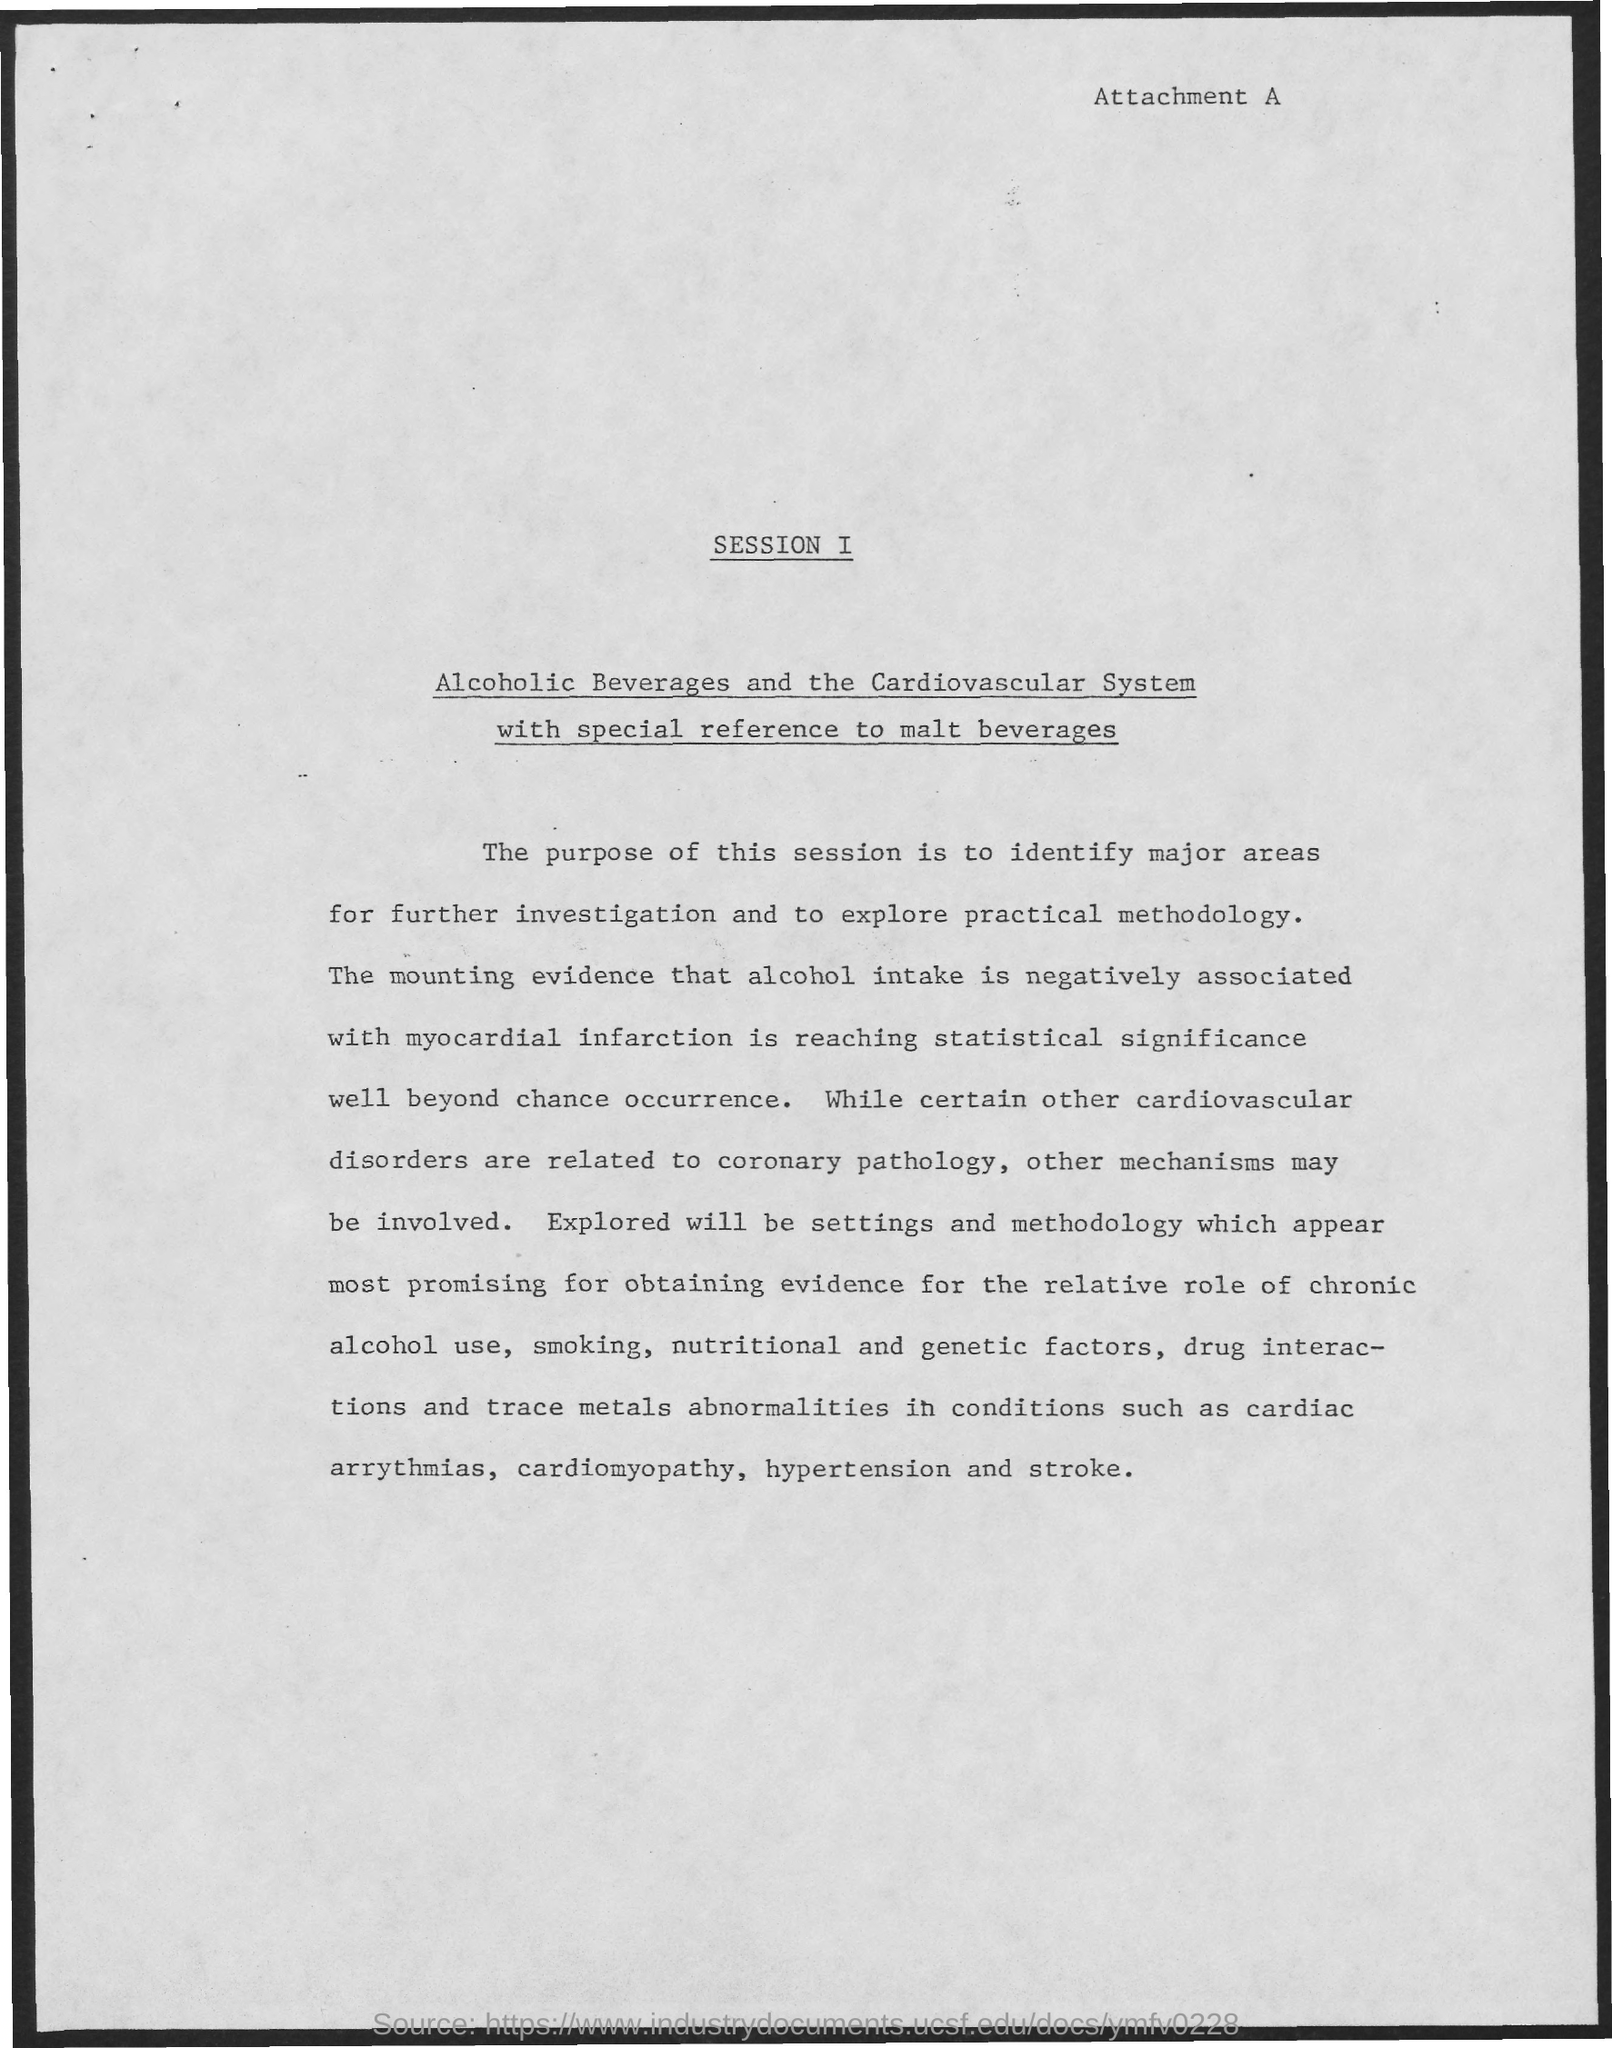Mention a couple of crucial points in this snapshot. The title of the document written below the heading "Session I" is "Alcoholic Beverages and the Cardiovascular System with special reference to malt beverages. The purpose of this session is to identify major areas for further investigation and to explore practical methodology for conducting such investigations. The document has text written on the top right side, which is labeled as "Attachment A. Alcohol consumption is negatively associated with myocardial infarction, meaning that individuals who consume alcohol are at a higher risk for experiencing a myocardial infarction compared to those who do not consume alcohol. The purpose of the session is to identify major areas for further investigation and to explore practical methodology for conducting research in the field. 